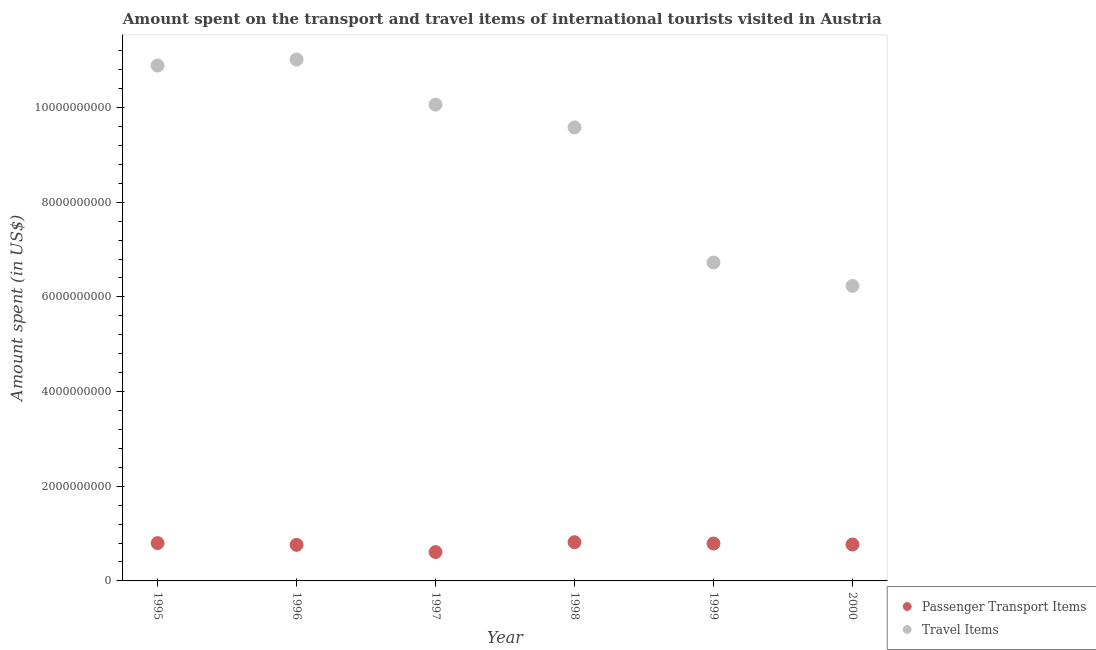How many different coloured dotlines are there?
Ensure brevity in your answer.  2. Is the number of dotlines equal to the number of legend labels?
Your answer should be compact. Yes. What is the amount spent on passenger transport items in 1998?
Your response must be concise. 8.18e+08. Across all years, what is the maximum amount spent in travel items?
Provide a succinct answer. 1.10e+1. Across all years, what is the minimum amount spent in travel items?
Offer a terse response. 6.23e+09. In which year was the amount spent in travel items maximum?
Ensure brevity in your answer.  1996. What is the total amount spent on passenger transport items in the graph?
Provide a succinct answer. 4.55e+09. What is the difference between the amount spent on passenger transport items in 1996 and that in 1998?
Ensure brevity in your answer.  -5.60e+07. What is the difference between the amount spent on passenger transport items in 1997 and the amount spent in travel items in 1998?
Provide a succinct answer. -8.97e+09. What is the average amount spent in travel items per year?
Your answer should be very brief. 9.08e+09. In the year 1997, what is the difference between the amount spent on passenger transport items and amount spent in travel items?
Provide a short and direct response. -9.45e+09. What is the ratio of the amount spent on passenger transport items in 1996 to that in 1999?
Your response must be concise. 0.96. What is the difference between the highest and the second highest amount spent in travel items?
Provide a short and direct response. 1.28e+08. What is the difference between the highest and the lowest amount spent in travel items?
Provide a succinct answer. 4.78e+09. In how many years, is the amount spent in travel items greater than the average amount spent in travel items taken over all years?
Offer a terse response. 4. Does the amount spent on passenger transport items monotonically increase over the years?
Keep it short and to the point. No. Is the amount spent on passenger transport items strictly greater than the amount spent in travel items over the years?
Provide a short and direct response. No. How many years are there in the graph?
Keep it short and to the point. 6. What is the difference between two consecutive major ticks on the Y-axis?
Offer a terse response. 2.00e+09. Are the values on the major ticks of Y-axis written in scientific E-notation?
Provide a succinct answer. No. Where does the legend appear in the graph?
Offer a very short reply. Bottom right. How are the legend labels stacked?
Your answer should be compact. Vertical. What is the title of the graph?
Your response must be concise. Amount spent on the transport and travel items of international tourists visited in Austria. Does "Nitrous oxide" appear as one of the legend labels in the graph?
Provide a succinct answer. No. What is the label or title of the Y-axis?
Your answer should be compact. Amount spent (in US$). What is the Amount spent (in US$) in Passenger Transport Items in 1995?
Your answer should be very brief. 7.99e+08. What is the Amount spent (in US$) in Travel Items in 1995?
Offer a very short reply. 1.09e+1. What is the Amount spent (in US$) in Passenger Transport Items in 1996?
Provide a short and direct response. 7.62e+08. What is the Amount spent (in US$) of Travel Items in 1996?
Give a very brief answer. 1.10e+1. What is the Amount spent (in US$) of Passenger Transport Items in 1997?
Make the answer very short. 6.10e+08. What is the Amount spent (in US$) in Travel Items in 1997?
Provide a short and direct response. 1.01e+1. What is the Amount spent (in US$) of Passenger Transport Items in 1998?
Offer a terse response. 8.18e+08. What is the Amount spent (in US$) in Travel Items in 1998?
Offer a terse response. 9.58e+09. What is the Amount spent (in US$) of Passenger Transport Items in 1999?
Your response must be concise. 7.90e+08. What is the Amount spent (in US$) of Travel Items in 1999?
Offer a very short reply. 6.73e+09. What is the Amount spent (in US$) of Passenger Transport Items in 2000?
Give a very brief answer. 7.69e+08. What is the Amount spent (in US$) in Travel Items in 2000?
Provide a short and direct response. 6.23e+09. Across all years, what is the maximum Amount spent (in US$) in Passenger Transport Items?
Make the answer very short. 8.18e+08. Across all years, what is the maximum Amount spent (in US$) of Travel Items?
Offer a terse response. 1.10e+1. Across all years, what is the minimum Amount spent (in US$) of Passenger Transport Items?
Ensure brevity in your answer.  6.10e+08. Across all years, what is the minimum Amount spent (in US$) of Travel Items?
Your response must be concise. 6.23e+09. What is the total Amount spent (in US$) of Passenger Transport Items in the graph?
Offer a very short reply. 4.55e+09. What is the total Amount spent (in US$) in Travel Items in the graph?
Your answer should be very brief. 5.45e+1. What is the difference between the Amount spent (in US$) in Passenger Transport Items in 1995 and that in 1996?
Offer a very short reply. 3.70e+07. What is the difference between the Amount spent (in US$) of Travel Items in 1995 and that in 1996?
Your response must be concise. -1.28e+08. What is the difference between the Amount spent (in US$) in Passenger Transport Items in 1995 and that in 1997?
Offer a terse response. 1.89e+08. What is the difference between the Amount spent (in US$) of Travel Items in 1995 and that in 1997?
Your response must be concise. 8.25e+08. What is the difference between the Amount spent (in US$) of Passenger Transport Items in 1995 and that in 1998?
Your response must be concise. -1.90e+07. What is the difference between the Amount spent (in US$) in Travel Items in 1995 and that in 1998?
Make the answer very short. 1.31e+09. What is the difference between the Amount spent (in US$) in Passenger Transport Items in 1995 and that in 1999?
Give a very brief answer. 9.00e+06. What is the difference between the Amount spent (in US$) in Travel Items in 1995 and that in 1999?
Ensure brevity in your answer.  4.16e+09. What is the difference between the Amount spent (in US$) of Passenger Transport Items in 1995 and that in 2000?
Your response must be concise. 3.00e+07. What is the difference between the Amount spent (in US$) of Travel Items in 1995 and that in 2000?
Keep it short and to the point. 4.66e+09. What is the difference between the Amount spent (in US$) of Passenger Transport Items in 1996 and that in 1997?
Provide a short and direct response. 1.52e+08. What is the difference between the Amount spent (in US$) in Travel Items in 1996 and that in 1997?
Provide a short and direct response. 9.53e+08. What is the difference between the Amount spent (in US$) of Passenger Transport Items in 1996 and that in 1998?
Keep it short and to the point. -5.60e+07. What is the difference between the Amount spent (in US$) in Travel Items in 1996 and that in 1998?
Ensure brevity in your answer.  1.43e+09. What is the difference between the Amount spent (in US$) in Passenger Transport Items in 1996 and that in 1999?
Your answer should be very brief. -2.80e+07. What is the difference between the Amount spent (in US$) of Travel Items in 1996 and that in 1999?
Your response must be concise. 4.29e+09. What is the difference between the Amount spent (in US$) in Passenger Transport Items in 1996 and that in 2000?
Your answer should be very brief. -7.00e+06. What is the difference between the Amount spent (in US$) in Travel Items in 1996 and that in 2000?
Ensure brevity in your answer.  4.78e+09. What is the difference between the Amount spent (in US$) of Passenger Transport Items in 1997 and that in 1998?
Your answer should be compact. -2.08e+08. What is the difference between the Amount spent (in US$) in Travel Items in 1997 and that in 1998?
Provide a succinct answer. 4.81e+08. What is the difference between the Amount spent (in US$) of Passenger Transport Items in 1997 and that in 1999?
Your answer should be very brief. -1.80e+08. What is the difference between the Amount spent (in US$) of Travel Items in 1997 and that in 1999?
Offer a terse response. 3.34e+09. What is the difference between the Amount spent (in US$) of Passenger Transport Items in 1997 and that in 2000?
Your answer should be compact. -1.59e+08. What is the difference between the Amount spent (in US$) in Travel Items in 1997 and that in 2000?
Offer a very short reply. 3.83e+09. What is the difference between the Amount spent (in US$) in Passenger Transport Items in 1998 and that in 1999?
Offer a very short reply. 2.80e+07. What is the difference between the Amount spent (in US$) of Travel Items in 1998 and that in 1999?
Provide a short and direct response. 2.85e+09. What is the difference between the Amount spent (in US$) of Passenger Transport Items in 1998 and that in 2000?
Provide a short and direct response. 4.90e+07. What is the difference between the Amount spent (in US$) of Travel Items in 1998 and that in 2000?
Offer a very short reply. 3.35e+09. What is the difference between the Amount spent (in US$) of Passenger Transport Items in 1999 and that in 2000?
Your answer should be compact. 2.10e+07. What is the difference between the Amount spent (in US$) of Travel Items in 1999 and that in 2000?
Keep it short and to the point. 4.95e+08. What is the difference between the Amount spent (in US$) in Passenger Transport Items in 1995 and the Amount spent (in US$) in Travel Items in 1996?
Provide a short and direct response. -1.02e+1. What is the difference between the Amount spent (in US$) of Passenger Transport Items in 1995 and the Amount spent (in US$) of Travel Items in 1997?
Make the answer very short. -9.26e+09. What is the difference between the Amount spent (in US$) of Passenger Transport Items in 1995 and the Amount spent (in US$) of Travel Items in 1998?
Provide a short and direct response. -8.78e+09. What is the difference between the Amount spent (in US$) in Passenger Transport Items in 1995 and the Amount spent (in US$) in Travel Items in 1999?
Provide a short and direct response. -5.93e+09. What is the difference between the Amount spent (in US$) in Passenger Transport Items in 1995 and the Amount spent (in US$) in Travel Items in 2000?
Provide a short and direct response. -5.43e+09. What is the difference between the Amount spent (in US$) in Passenger Transport Items in 1996 and the Amount spent (in US$) in Travel Items in 1997?
Your answer should be compact. -9.30e+09. What is the difference between the Amount spent (in US$) of Passenger Transport Items in 1996 and the Amount spent (in US$) of Travel Items in 1998?
Provide a short and direct response. -8.82e+09. What is the difference between the Amount spent (in US$) of Passenger Transport Items in 1996 and the Amount spent (in US$) of Travel Items in 1999?
Make the answer very short. -5.96e+09. What is the difference between the Amount spent (in US$) in Passenger Transport Items in 1996 and the Amount spent (in US$) in Travel Items in 2000?
Your response must be concise. -5.47e+09. What is the difference between the Amount spent (in US$) of Passenger Transport Items in 1997 and the Amount spent (in US$) of Travel Items in 1998?
Make the answer very short. -8.97e+09. What is the difference between the Amount spent (in US$) in Passenger Transport Items in 1997 and the Amount spent (in US$) in Travel Items in 1999?
Give a very brief answer. -6.12e+09. What is the difference between the Amount spent (in US$) in Passenger Transport Items in 1997 and the Amount spent (in US$) in Travel Items in 2000?
Provide a succinct answer. -5.62e+09. What is the difference between the Amount spent (in US$) of Passenger Transport Items in 1998 and the Amount spent (in US$) of Travel Items in 1999?
Offer a terse response. -5.91e+09. What is the difference between the Amount spent (in US$) of Passenger Transport Items in 1998 and the Amount spent (in US$) of Travel Items in 2000?
Your response must be concise. -5.41e+09. What is the difference between the Amount spent (in US$) of Passenger Transport Items in 1999 and the Amount spent (in US$) of Travel Items in 2000?
Make the answer very short. -5.44e+09. What is the average Amount spent (in US$) of Passenger Transport Items per year?
Your answer should be compact. 7.58e+08. What is the average Amount spent (in US$) in Travel Items per year?
Your answer should be compact. 9.08e+09. In the year 1995, what is the difference between the Amount spent (in US$) of Passenger Transport Items and Amount spent (in US$) of Travel Items?
Keep it short and to the point. -1.01e+1. In the year 1996, what is the difference between the Amount spent (in US$) in Passenger Transport Items and Amount spent (in US$) in Travel Items?
Offer a terse response. -1.03e+1. In the year 1997, what is the difference between the Amount spent (in US$) in Passenger Transport Items and Amount spent (in US$) in Travel Items?
Offer a very short reply. -9.45e+09. In the year 1998, what is the difference between the Amount spent (in US$) in Passenger Transport Items and Amount spent (in US$) in Travel Items?
Ensure brevity in your answer.  -8.76e+09. In the year 1999, what is the difference between the Amount spent (in US$) of Passenger Transport Items and Amount spent (in US$) of Travel Items?
Offer a terse response. -5.94e+09. In the year 2000, what is the difference between the Amount spent (in US$) of Passenger Transport Items and Amount spent (in US$) of Travel Items?
Offer a very short reply. -5.46e+09. What is the ratio of the Amount spent (in US$) in Passenger Transport Items in 1995 to that in 1996?
Your answer should be compact. 1.05. What is the ratio of the Amount spent (in US$) in Travel Items in 1995 to that in 1996?
Keep it short and to the point. 0.99. What is the ratio of the Amount spent (in US$) in Passenger Transport Items in 1995 to that in 1997?
Offer a very short reply. 1.31. What is the ratio of the Amount spent (in US$) of Travel Items in 1995 to that in 1997?
Keep it short and to the point. 1.08. What is the ratio of the Amount spent (in US$) of Passenger Transport Items in 1995 to that in 1998?
Your answer should be very brief. 0.98. What is the ratio of the Amount spent (in US$) in Travel Items in 1995 to that in 1998?
Offer a terse response. 1.14. What is the ratio of the Amount spent (in US$) of Passenger Transport Items in 1995 to that in 1999?
Offer a terse response. 1.01. What is the ratio of the Amount spent (in US$) in Travel Items in 1995 to that in 1999?
Keep it short and to the point. 1.62. What is the ratio of the Amount spent (in US$) in Passenger Transport Items in 1995 to that in 2000?
Your response must be concise. 1.04. What is the ratio of the Amount spent (in US$) in Travel Items in 1995 to that in 2000?
Provide a succinct answer. 1.75. What is the ratio of the Amount spent (in US$) in Passenger Transport Items in 1996 to that in 1997?
Ensure brevity in your answer.  1.25. What is the ratio of the Amount spent (in US$) of Travel Items in 1996 to that in 1997?
Your answer should be compact. 1.09. What is the ratio of the Amount spent (in US$) of Passenger Transport Items in 1996 to that in 1998?
Make the answer very short. 0.93. What is the ratio of the Amount spent (in US$) of Travel Items in 1996 to that in 1998?
Provide a short and direct response. 1.15. What is the ratio of the Amount spent (in US$) of Passenger Transport Items in 1996 to that in 1999?
Your answer should be very brief. 0.96. What is the ratio of the Amount spent (in US$) in Travel Items in 1996 to that in 1999?
Your answer should be compact. 1.64. What is the ratio of the Amount spent (in US$) in Passenger Transport Items in 1996 to that in 2000?
Your response must be concise. 0.99. What is the ratio of the Amount spent (in US$) of Travel Items in 1996 to that in 2000?
Give a very brief answer. 1.77. What is the ratio of the Amount spent (in US$) in Passenger Transport Items in 1997 to that in 1998?
Give a very brief answer. 0.75. What is the ratio of the Amount spent (in US$) of Travel Items in 1997 to that in 1998?
Your answer should be compact. 1.05. What is the ratio of the Amount spent (in US$) in Passenger Transport Items in 1997 to that in 1999?
Provide a short and direct response. 0.77. What is the ratio of the Amount spent (in US$) in Travel Items in 1997 to that in 1999?
Your answer should be compact. 1.5. What is the ratio of the Amount spent (in US$) in Passenger Transport Items in 1997 to that in 2000?
Provide a succinct answer. 0.79. What is the ratio of the Amount spent (in US$) of Travel Items in 1997 to that in 2000?
Your response must be concise. 1.61. What is the ratio of the Amount spent (in US$) in Passenger Transport Items in 1998 to that in 1999?
Offer a terse response. 1.04. What is the ratio of the Amount spent (in US$) in Travel Items in 1998 to that in 1999?
Provide a short and direct response. 1.42. What is the ratio of the Amount spent (in US$) in Passenger Transport Items in 1998 to that in 2000?
Provide a succinct answer. 1.06. What is the ratio of the Amount spent (in US$) of Travel Items in 1998 to that in 2000?
Ensure brevity in your answer.  1.54. What is the ratio of the Amount spent (in US$) of Passenger Transport Items in 1999 to that in 2000?
Your answer should be very brief. 1.03. What is the ratio of the Amount spent (in US$) of Travel Items in 1999 to that in 2000?
Offer a terse response. 1.08. What is the difference between the highest and the second highest Amount spent (in US$) in Passenger Transport Items?
Your response must be concise. 1.90e+07. What is the difference between the highest and the second highest Amount spent (in US$) of Travel Items?
Provide a short and direct response. 1.28e+08. What is the difference between the highest and the lowest Amount spent (in US$) of Passenger Transport Items?
Offer a very short reply. 2.08e+08. What is the difference between the highest and the lowest Amount spent (in US$) of Travel Items?
Your answer should be very brief. 4.78e+09. 